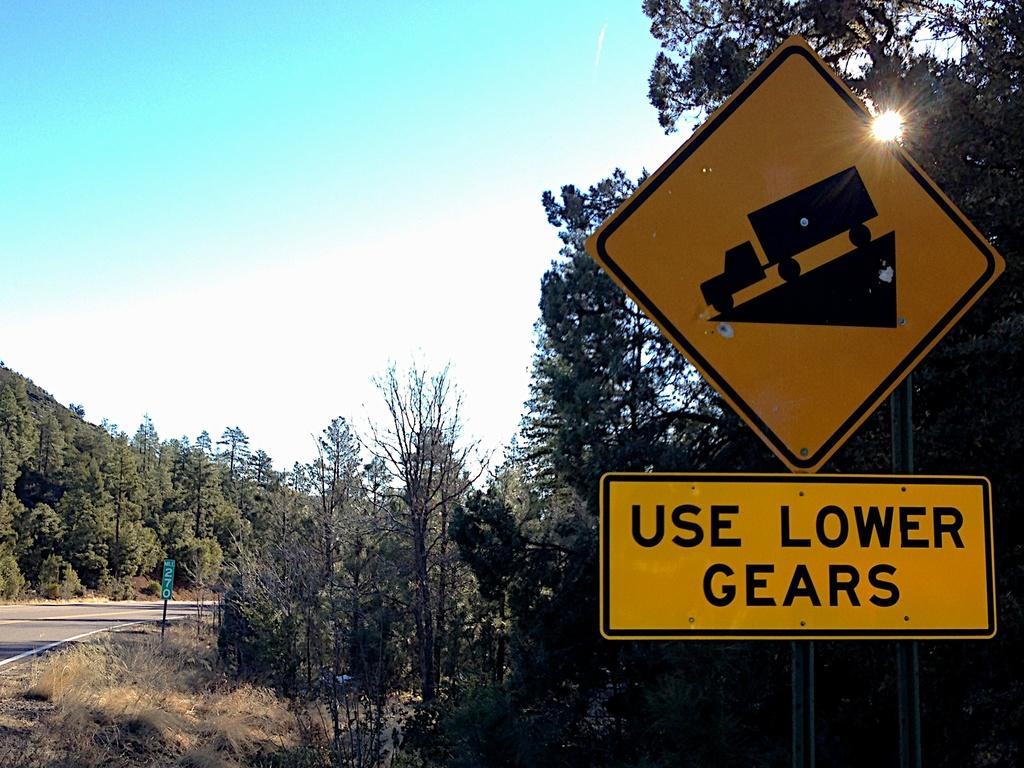<image>
Summarize the visual content of the image. A sign instructs truck drivers to use lower gears. 